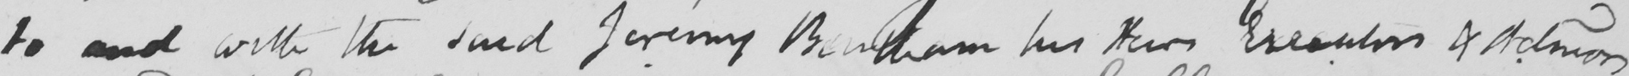Can you tell me what this handwritten text says? to and with the said Jeremy Bentham his heirs Executors & Admins 